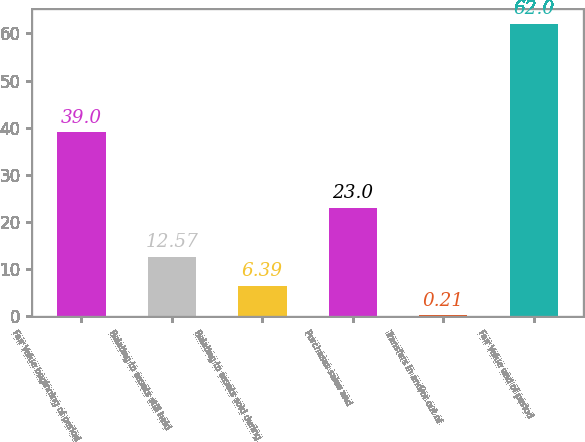Convert chart to OTSL. <chart><loc_0><loc_0><loc_500><loc_500><bar_chart><fcel>Fair Value beginning of period<fcel>Relating to assets still held<fcel>Relating to assets sold during<fcel>Purchases sales and<fcel>Transfers in and/or out of<fcel>Fair Value end of period<nl><fcel>39<fcel>12.57<fcel>6.39<fcel>23<fcel>0.21<fcel>62<nl></chart> 